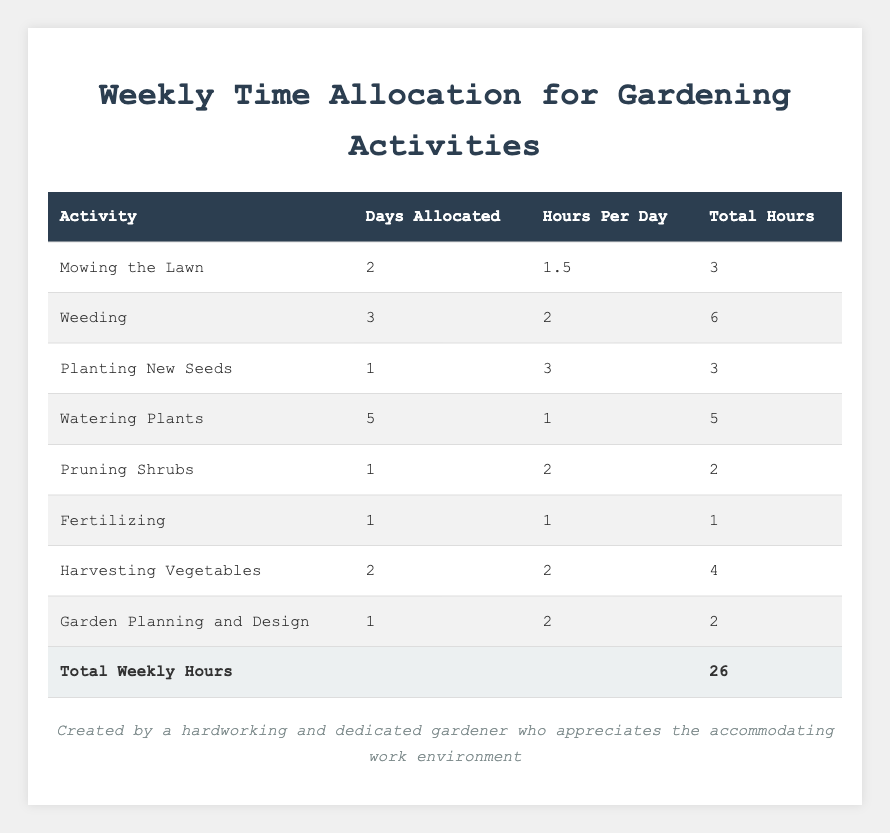What is the total hours allocated for Weeding? The table states that Weeding has a total of 6 hours allocated.
Answer: 6 hours How many days are allocated for Watering Plants? According to the table, Watering Plants is allocated for 5 days.
Answer: 5 days What is the total number of hours spent on Mowing the Lawn and Planting New Seeds combined? Mowing the Lawn has 3 total hours and Planting New Seeds has 3 total hours, so adding them together gives 3 + 3 = 6 total hours.
Answer: 6 hours Is the total number of hours allocated for Fertilizing greater than 2 hours? The total hours for Fertilizing is 1 hour, which is not greater than 2 hours.
Answer: No How many more hours are allocated for Weeding than for Pruning Shrubs? Weeding has 6 hours, while Pruning Shrubs has 2 hours. Subtracting gives 6 - 2 = 4 hours more allocated for Weeding.
Answer: 4 hours What is the average number of hours allocated per activity? There are 8 activities in total, and the total hours is 26. Dividing gives 26 / 8 = 3.25 hours per activity on average.
Answer: 3.25 hours Which activity has the least number of total hours allocated? By reviewing the table, Fertilizing has the least number of total hours at 1 hour.
Answer: Fertilizing What is the total number of days allocated for the activities that involve planting (including Planting New Seeds and Harvesting Vegetables)? Planting New Seeds is allocated for 1 day, and Harvesting Vegetables is allocated for 2 days. Adding these gives 1 + 2 = 3 days total.
Answer: 3 days How many total hours are allocated for all activities excluding Watering Plants? Total hours is 26 hours; Watering Plants has 5 hours. Subtracting those gives 26 - 5 = 21 hours for all other activities.
Answer: 21 hours Is the combined total of Mowing the Lawn and Harvesting Vegetables greater than the total for Weeding? Mowing the Lawn has 3 hours and Harvesting Vegetables has 4 hours. Combined they give 3 + 4 = 7 hours, which is greater than Weeding's 6 hours.
Answer: Yes 